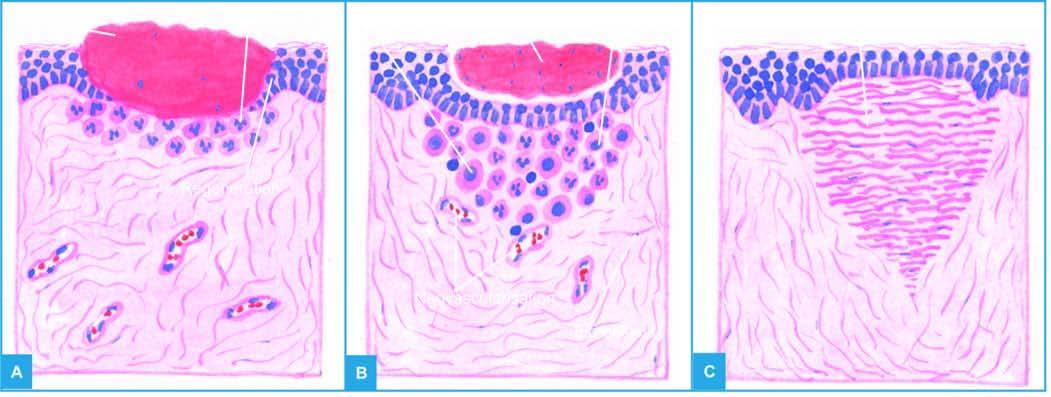does the margin spur from the margins of wound?
Answer the question using a single word or phrase. No 